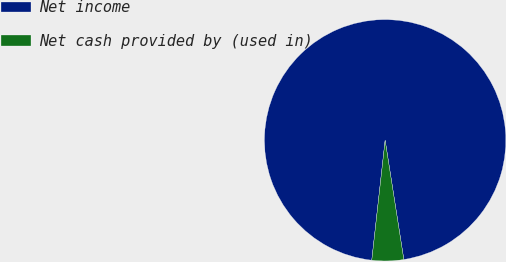<chart> <loc_0><loc_0><loc_500><loc_500><pie_chart><fcel>Net income<fcel>Net cash provided by (used in)<nl><fcel>95.76%<fcel>4.24%<nl></chart> 